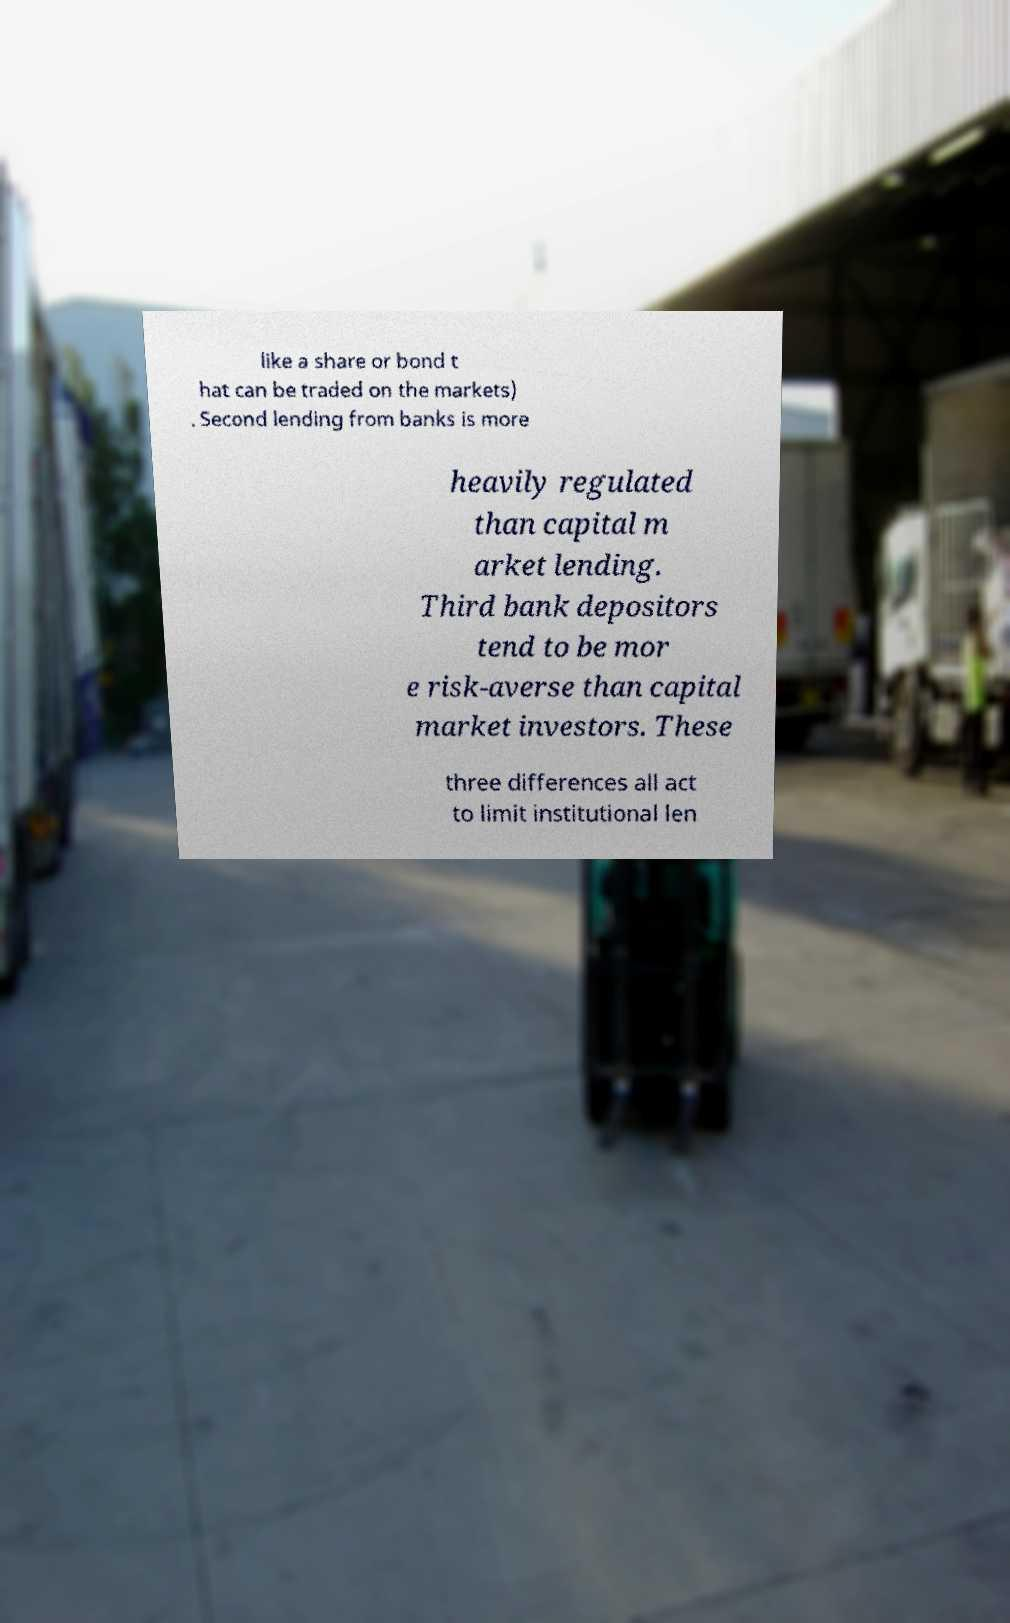What messages or text are displayed in this image? I need them in a readable, typed format. like a share or bond t hat can be traded on the markets) . Second lending from banks is more heavily regulated than capital m arket lending. Third bank depositors tend to be mor e risk-averse than capital market investors. These three differences all act to limit institutional len 